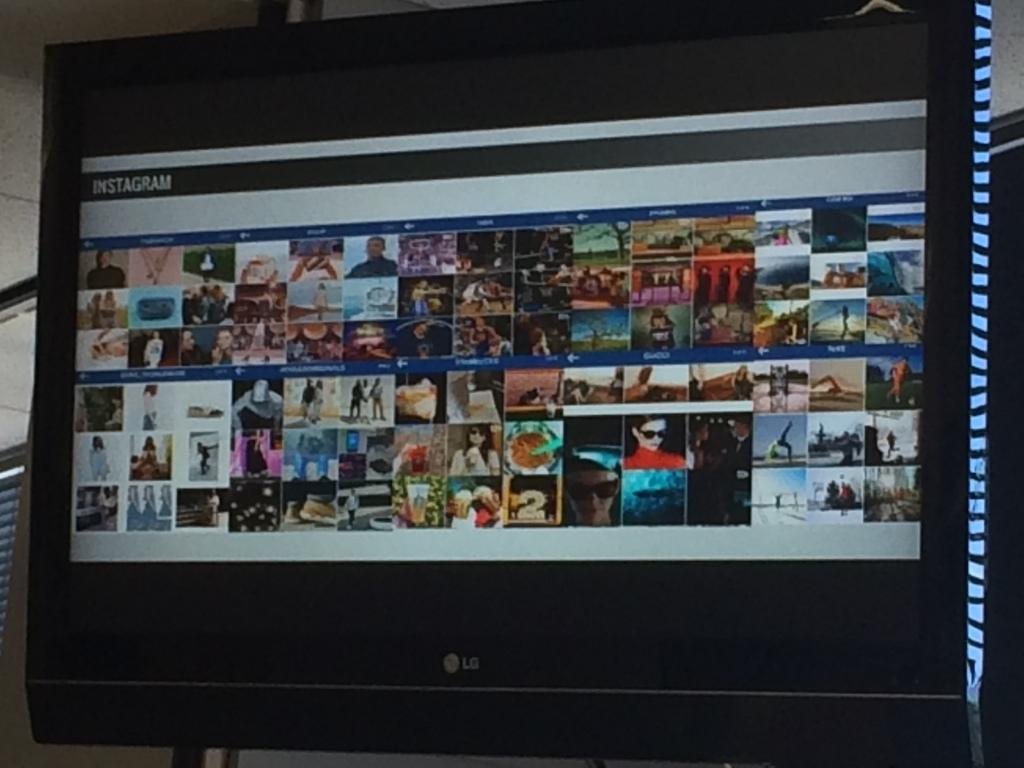<image>
Provide a brief description of the given image. A flat screen monitor showing Instagram photos says LG on the front. 